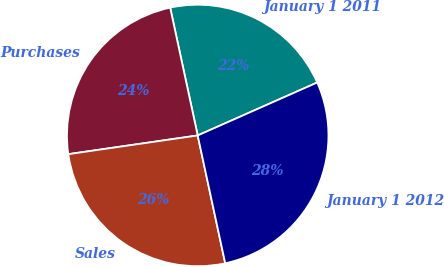<chart> <loc_0><loc_0><loc_500><loc_500><pie_chart><fcel>January 1 2011<fcel>Purchases<fcel>Sales<fcel>January 1 2012<nl><fcel>21.74%<fcel>23.91%<fcel>26.09%<fcel>28.26%<nl></chart> 